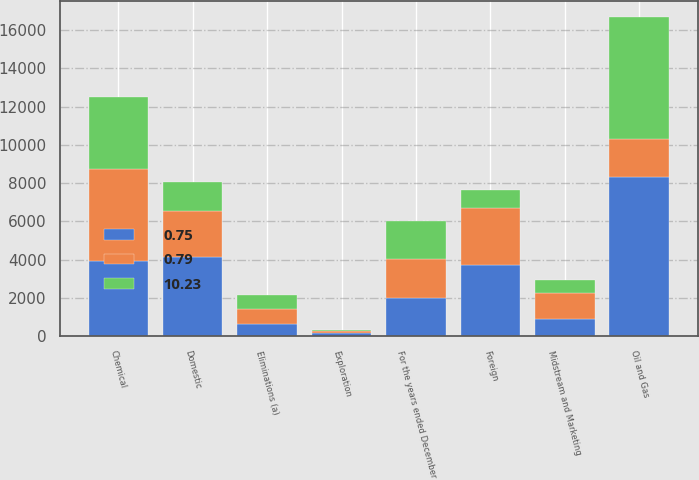<chart> <loc_0><loc_0><loc_500><loc_500><stacked_bar_chart><ecel><fcel>For the years ended December<fcel>Oil and Gas<fcel>Chemical<fcel>Midstream and Marketing<fcel>Eliminations (a)<fcel>Domestic<fcel>Foreign<fcel>Exploration<nl><fcel>10.23<fcel>2016<fcel>6377<fcel>3756<fcel>684<fcel>727<fcel>1552<fcel>965<fcel>49<nl><fcel>0.75<fcel>2015<fcel>8304<fcel>3945<fcel>891<fcel>660<fcel>4151<fcel>3747<fcel>162<nl><fcel>0.79<fcel>2014<fcel>2014<fcel>4817<fcel>1373<fcel>765<fcel>2381<fcel>2935<fcel>126<nl></chart> 